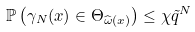<formula> <loc_0><loc_0><loc_500><loc_500>\mathbb { P } \left ( \gamma _ { N } ( x ) \in \Theta _ { \widehat { \omega } ( x ) } \right ) \leq \chi \tilde { q } ^ { N }</formula> 